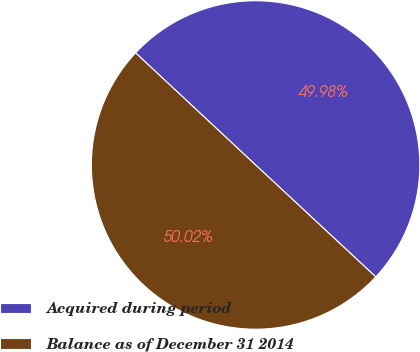<chart> <loc_0><loc_0><loc_500><loc_500><pie_chart><fcel>Acquired during period<fcel>Balance as of December 31 2014<nl><fcel>49.98%<fcel>50.02%<nl></chart> 